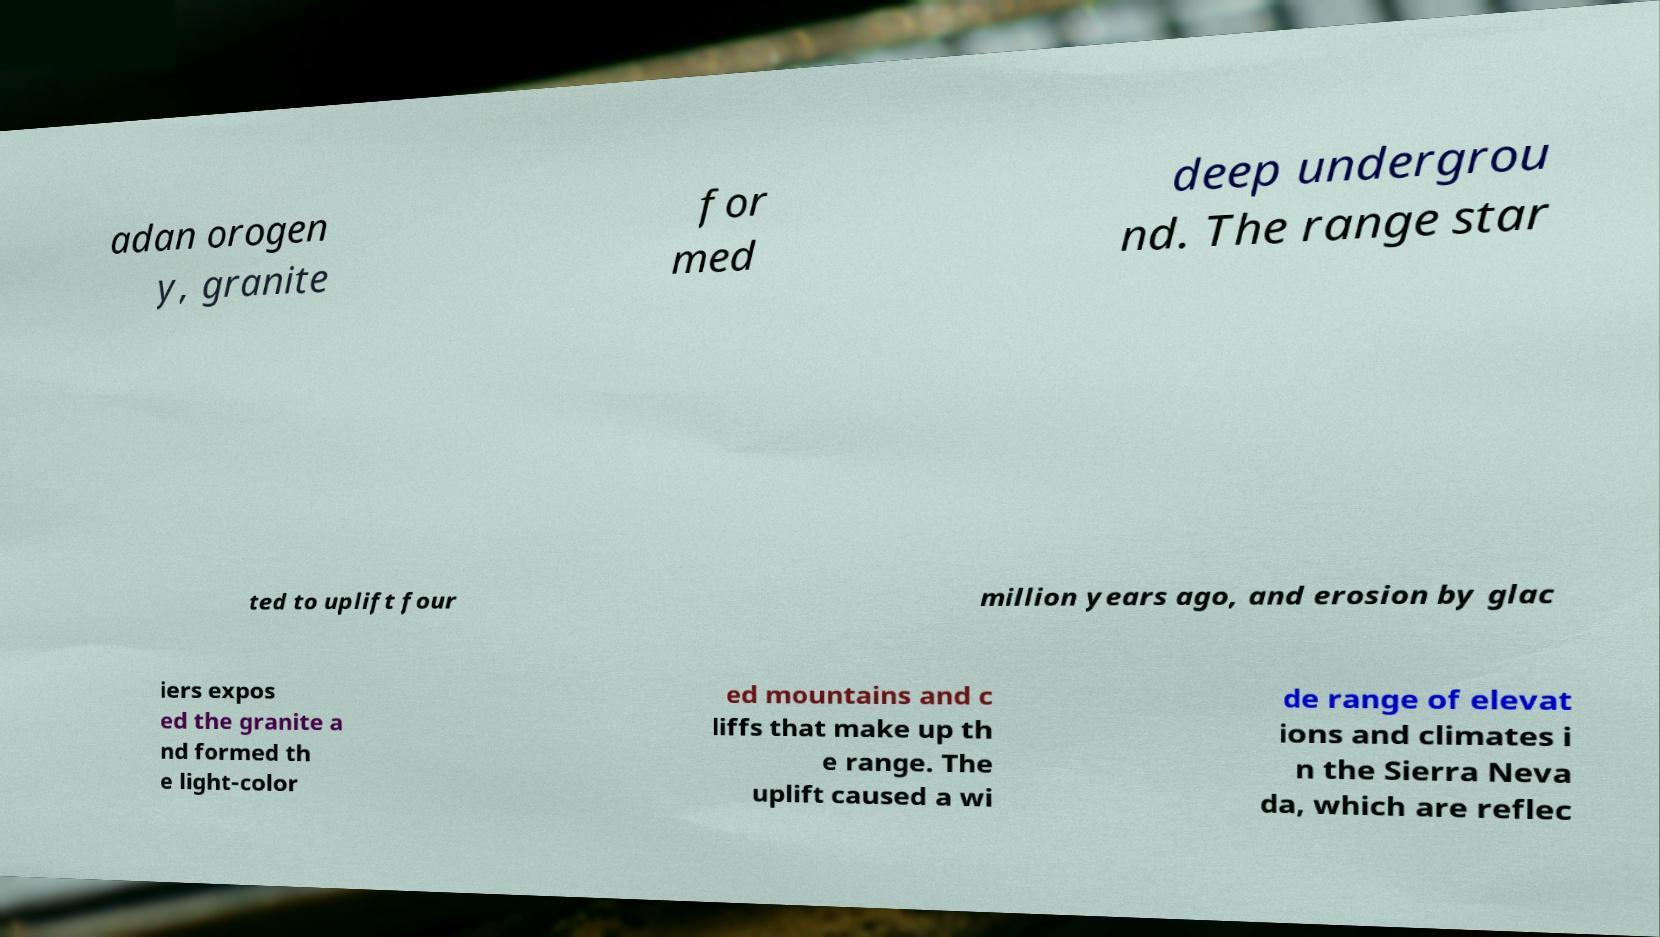Please identify and transcribe the text found in this image. adan orogen y, granite for med deep undergrou nd. The range star ted to uplift four million years ago, and erosion by glac iers expos ed the granite a nd formed th e light-color ed mountains and c liffs that make up th e range. The uplift caused a wi de range of elevat ions and climates i n the Sierra Neva da, which are reflec 